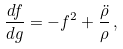Convert formula to latex. <formula><loc_0><loc_0><loc_500><loc_500>\frac { d f } { d g } = - f ^ { 2 } + \frac { \ddot { \rho } } { \rho } \, ,</formula> 